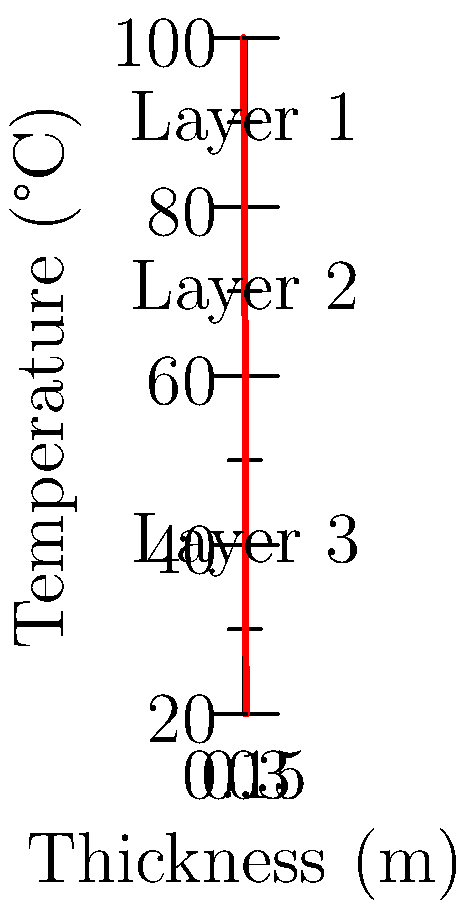A composite wall consists of three layers with thicknesses of 0.1 m each. The temperature profile across the wall is shown in the graph. Given that the thermal conductivities of the layers are $k_1 = 50$ W/(m·K), $k_2 = 30$ W/(m·K), and $k_3 = 20$ W/(m·K), calculate the heat transfer rate per unit area through the wall. To solve this problem, we'll use Fourier's law of heat conduction and the concept of thermal resistance for composite walls. Let's break it down step-by-step:

1) First, we need to calculate the temperature difference across each layer:
   Layer 1: $\Delta T_1 = 100°C - 80°C = 20°C$
   Layer 2: $\Delta T_2 = 80°C - 60°C = 20°C$
   Layer 3: $\Delta T_3 = 60°C - 20°C = 40°C$

2) Now, we'll calculate the thermal resistance of each layer using the formula:
   $R = \frac{L}{k}$, where L is the thickness and k is the thermal conductivity.

   $R_1 = \frac{0.1}{50} = 0.002$ m²·K/W
   $R_2 = \frac{0.1}{30} = 0.00333$ m²·K/W
   $R_3 = \frac{0.1}{20} = 0.005$ m²·K/W

3) The total thermal resistance is the sum of individual resistances:
   $R_{total} = R_1 + R_2 + R_3 = 0.002 + 0.00333 + 0.005 = 0.01033$ m²·K/W

4) The total temperature difference across the wall is:
   $\Delta T_{total} = 100°C - 20°C = 80°C$

5) Now we can use Fourier's law to calculate the heat transfer rate per unit area:
   $q = \frac{\Delta T_{total}}{R_{total}} = \frac{80}{0.01033} = 7743.5$ W/m²

Therefore, the heat transfer rate per unit area through the wall is approximately 7743.5 W/m².
Answer: 7743.5 W/m² 